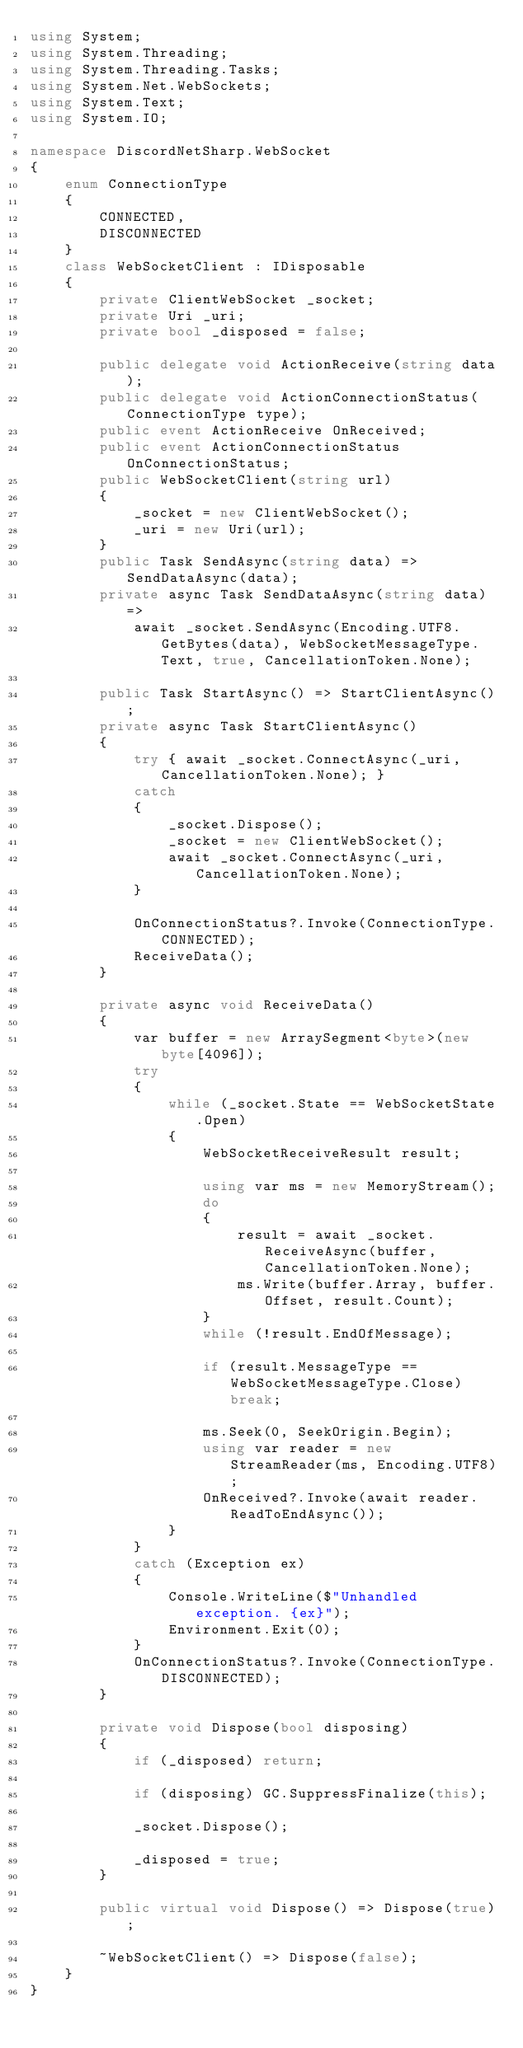<code> <loc_0><loc_0><loc_500><loc_500><_C#_>using System;
using System.Threading;
using System.Threading.Tasks;
using System.Net.WebSockets;
using System.Text;
using System.IO;

namespace DiscordNetSharp.WebSocket
{
	enum ConnectionType
	{
		CONNECTED,
		DISCONNECTED
	}
	class WebSocketClient : IDisposable
	{
		private ClientWebSocket _socket;
		private Uri _uri;
		private bool _disposed = false;

		public delegate void ActionReceive(string data);
		public delegate void ActionConnectionStatus(ConnectionType type);
		public event ActionReceive OnReceived;
		public event ActionConnectionStatus OnConnectionStatus;
		public WebSocketClient(string url)
		{
			_socket = new ClientWebSocket();
			_uri = new Uri(url);
		}
		public Task SendAsync(string data) => SendDataAsync(data);
		private async Task SendDataAsync(string data) =>
			await _socket.SendAsync(Encoding.UTF8.GetBytes(data), WebSocketMessageType.Text, true, CancellationToken.None);

		public Task StartAsync() => StartClientAsync();
		private async Task StartClientAsync()
		{
			try { await _socket.ConnectAsync(_uri, CancellationToken.None); }
			catch
			{
				_socket.Dispose();
				_socket = new ClientWebSocket();
				await _socket.ConnectAsync(_uri, CancellationToken.None);
			}

			OnConnectionStatus?.Invoke(ConnectionType.CONNECTED);
			ReceiveData();
		}

		private async void ReceiveData()
		{
			var buffer = new ArraySegment<byte>(new byte[4096]);
			try
			{
				while (_socket.State == WebSocketState.Open)
				{
					WebSocketReceiveResult result;

					using var ms = new MemoryStream();
					do
					{
						result = await _socket.ReceiveAsync(buffer, CancellationToken.None);
						ms.Write(buffer.Array, buffer.Offset, result.Count);
					}
					while (!result.EndOfMessage);

					if (result.MessageType == WebSocketMessageType.Close) break;

					ms.Seek(0, SeekOrigin.Begin);
					using var reader = new StreamReader(ms, Encoding.UTF8);
					OnReceived?.Invoke(await reader.ReadToEndAsync());
				}
			}
            catch (Exception ex)
			{
				Console.WriteLine($"Unhandled exception. {ex}");
				Environment.Exit(0);
			}
			OnConnectionStatus?.Invoke(ConnectionType.DISCONNECTED);
		}

		private void Dispose(bool disposing)
		{
			if (_disposed) return;

			if (disposing) GC.SuppressFinalize(this);

			_socket.Dispose();

			_disposed = true;
		}

		public virtual void Dispose() => Dispose(true);

		~WebSocketClient() => Dispose(false);
	}
}</code> 